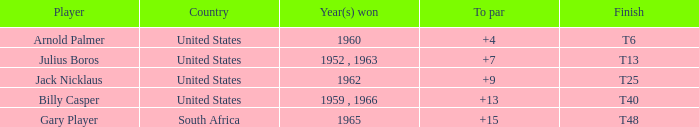What was gary player's highest sum when his to par was above 15? None. 